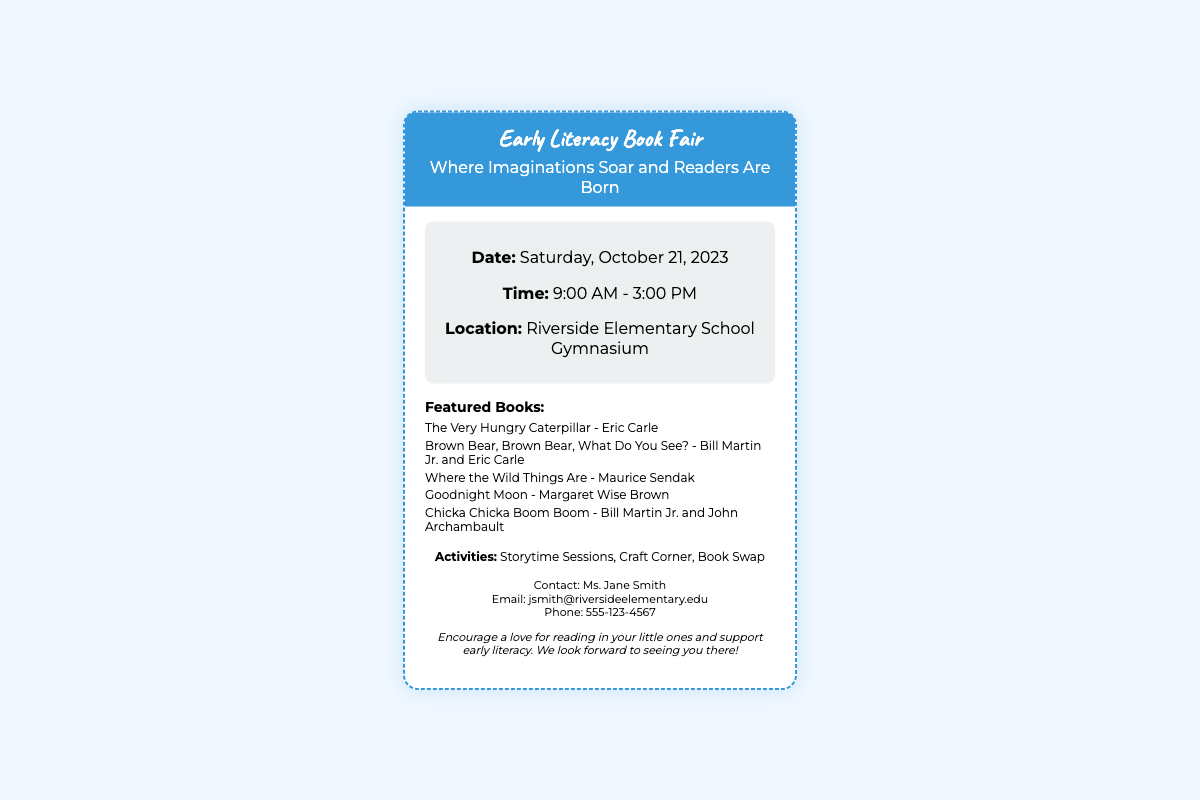What is the date of the book fair? The date of the book fair is specified in the document as Saturday, October 21, 2023.
Answer: Saturday, October 21, 2023 What time does the book fair start? The starting time of the book fair is indicated in the document as 9:00 AM.
Answer: 9:00 AM Where is the book fair located? The location of the book fair is provided in the document as Riverside Elementary School Gymnasium.
Answer: Riverside Elementary School Gymnasium Which book features a caterpillar? The document mentions a book about a caterpillar as one of the featured books.
Answer: The Very Hungry Caterpillar What activities are mentioned for the book fair? The document lists activities included in the book fair, which require synthesizing multiple pieces of information.
Answer: Storytime Sessions, Craft Corner, Book Swap Who is the contact person for the event? The document specifies a contact person for the event, providing their name as mentioned.
Answer: Ms. Jane Smith What is the main theme of the event? The theme of the event can be inferred from the title and subtitle given in the document, focusing on literacy.
Answer: Early Literacy How is the document structured? The structure of the document follows a specific layout that includes headings, lists, and sections, typical of a ticket.
Answer: Ticket format 